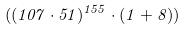Convert formula to latex. <formula><loc_0><loc_0><loc_500><loc_500>( ( 1 0 7 \cdot 5 1 ) ^ { 1 5 5 } \cdot ( 1 + 8 ) )</formula> 